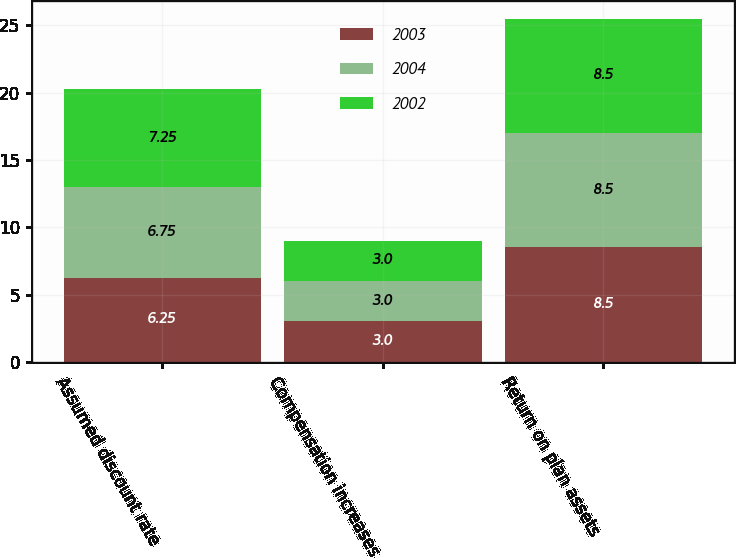<chart> <loc_0><loc_0><loc_500><loc_500><stacked_bar_chart><ecel><fcel>Assumed discount rate<fcel>Compensation increases<fcel>Return on plan assets<nl><fcel>2003<fcel>6.25<fcel>3<fcel>8.5<nl><fcel>2004<fcel>6.75<fcel>3<fcel>8.5<nl><fcel>2002<fcel>7.25<fcel>3<fcel>8.5<nl></chart> 